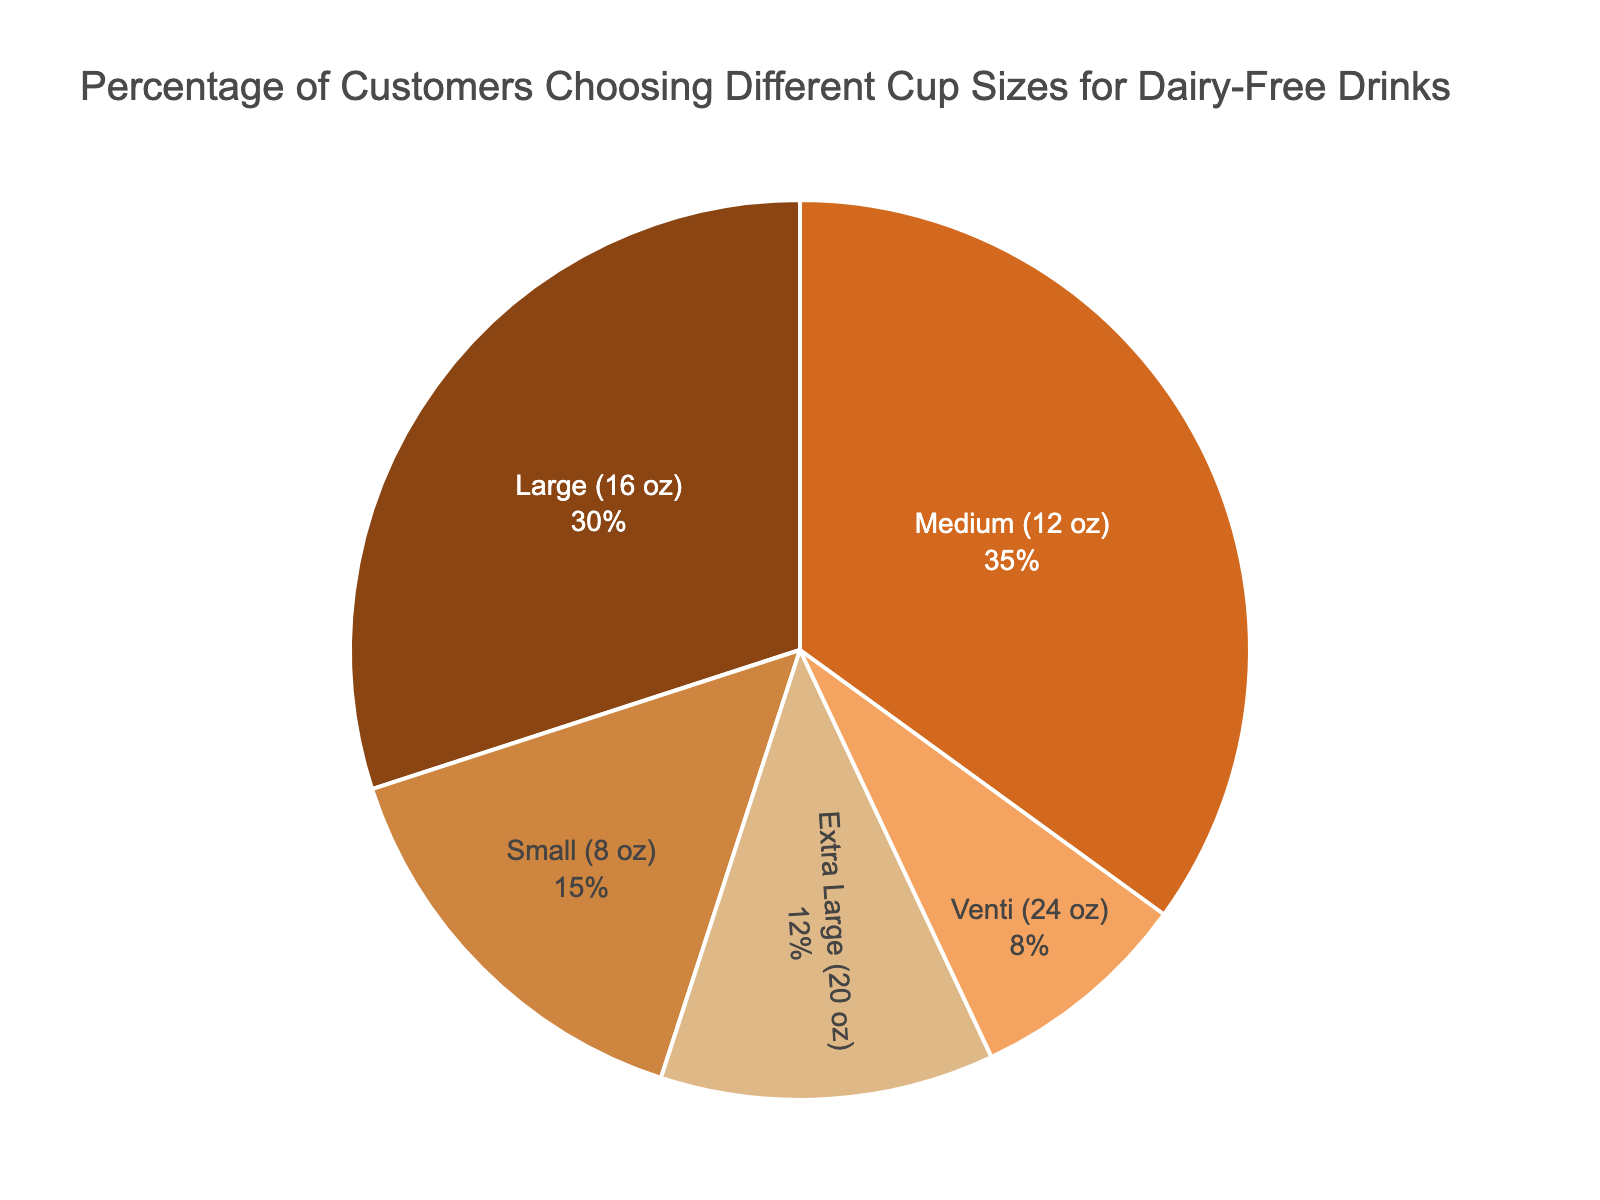What percentage of customers choose the Medium (12 oz) cup size? The Medium (12 oz) cup size has a segment in the pie chart which can be identified with its label. By checking the label, you see that 35% of customers choose the Medium cup size.
Answer: 35% Which cup size is preferred by more customers, Small (8 oz) or Large (16 oz)? The pie chart visually shows the segments for each cup size. Comparing the segments for Small (8 oz) and Large (16 oz), the Large segment is visibly larger. According to the data, 30% of customers choose Large, and 15% choose Small.
Answer: Large (16 oz) How much larger is the Medium (12 oz) segment compared to the Extra Large (20 oz) segment? To determine the difference, check the percentages of both the Medium (12 oz) and Extra Large (20 oz) segments. The Medium segment is 35%, and the Extra Large segment is 12%. Subtract 12% from 35%: 35% - 12% = 23%.
Answer: 23% Do more customers choose the Small (8 oz) or the Venti (24 oz) size? Compare the sizes of the segments for Small (8 oz) and Venti (24 oz). The Small segment is visibly larger. According to the data, 15% of customers choose Small, whereas 8% choose Venti.
Answer: Small (8 oz) What is the combined percentage of customers that choose either the Large (16 oz) or Medium (12 oz) sizes? Add the percentages of customers choosing Large (16 oz) and Medium (12 oz). The pie chart shows 30% for Large and 35% for Medium. Adding these: 30% + 35% = 65%.
Answer: 65% Which cup size has the smallest percentage of customers? Visually inspect the pie chart for the smallest segment. The Venti (24 oz) cup size has the smallest segment. According to the data, this segment represents 8% of the customers.
Answer: Venti (24 oz) How does the Extra Large (20 oz) segment visually compare to the Small (8 oz) segment? Visually, the Extra Large (20 oz) segment is smaller than the Small (8 oz) segment. By looking at the chart labels, the Extra Large size is 12%, and the Small size is 15%.
Answer: Extra Large (20 oz) is smaller What is the difference in percentage between the most popular and least popular cup sizes? Identify the most and least popular cup sizes. The Medium (12 oz) is the most popular at 35%, and the Venti (24 oz) is the least popular at 8%. Calculate the difference: 35% - 8% = 27%.
Answer: 27% What's the total percentage of customers choosing a cup size other than Small (8 oz)? Exclude the Small (8 oz) percentage, which is 15%. The remaining segments are Medium (12 oz) at 35%, Large (16 oz) at 30%, Extra Large (20 oz) at 12%, and Venti (24 oz) at 8%. Add these values: 35% + 30% + 12% + 8% = 85%.
Answer: 85% Which cup size is more popular, Medium (12 oz) or Extra Large (20 oz)? By comparing the size of the pie chart segments, the Medium (12 oz) segment is significantly larger than the Extra Large (20 oz) segment. The data confirms this: Medium at 35% and Extra Large at 12%.
Answer: Medium (12 oz) 